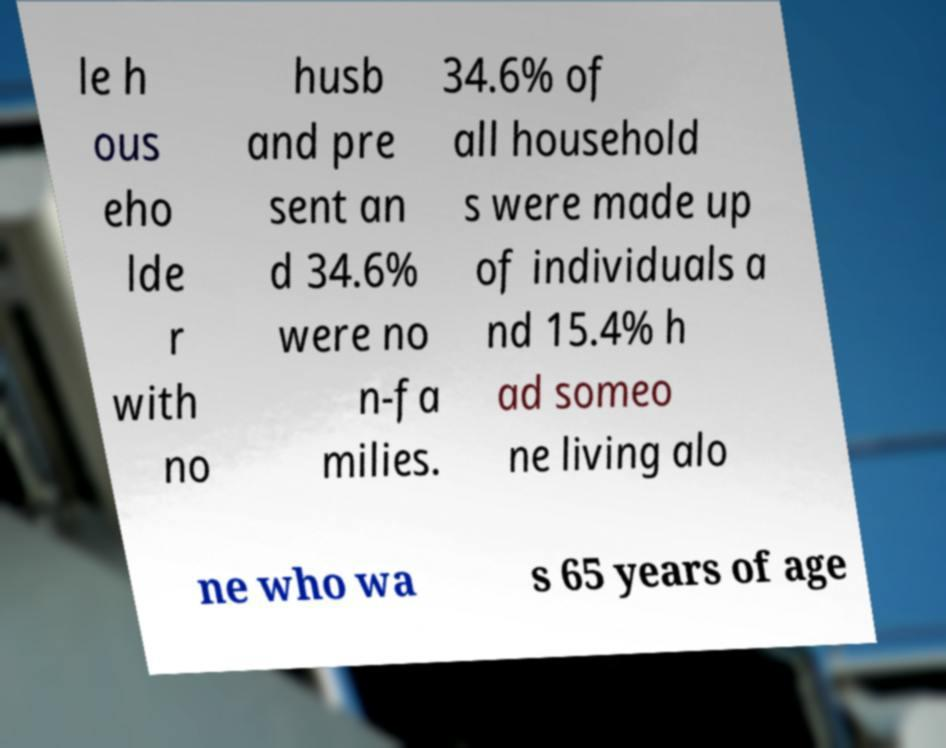I need the written content from this picture converted into text. Can you do that? The content of the picture seems to be statistical data, possibly from a report concerning household compositions. The visible text, although partially obscured by blur and angle, reveals details about the percentages of households with solo inhabitants and non-families. It mentions that 34.6% of all households were made up of individuals and that 15.4% had someone living alone who was 65 years of age or older. However, the limited view and quality of the image prevent a complete and accurate transcription. 